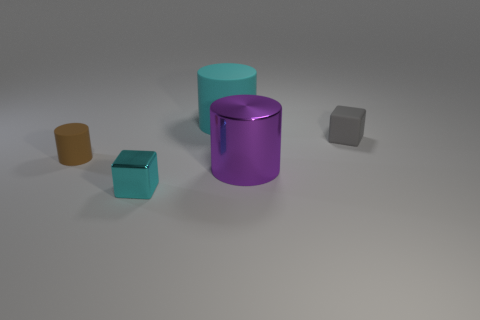Subtract all purple shiny cylinders. How many cylinders are left? 2 Subtract all gray cubes. How many cubes are left? 1 Add 3 big matte cylinders. How many objects exist? 8 Subtract 2 blocks. How many blocks are left? 0 Subtract all brown blocks. Subtract all green cylinders. How many blocks are left? 2 Subtract all small blue objects. Subtract all small gray rubber blocks. How many objects are left? 4 Add 1 big cylinders. How many big cylinders are left? 3 Add 4 cylinders. How many cylinders exist? 7 Subtract 0 yellow cylinders. How many objects are left? 5 Subtract all cylinders. How many objects are left? 2 